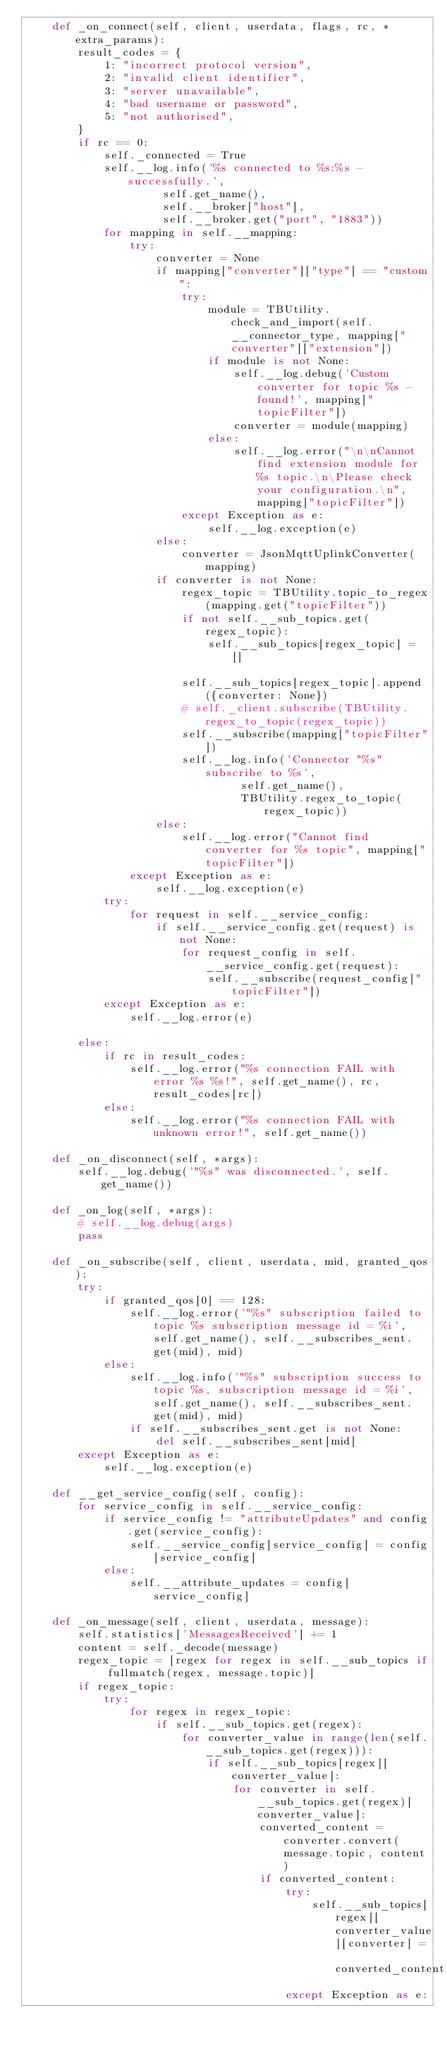Convert code to text. <code><loc_0><loc_0><loc_500><loc_500><_Python_>    def _on_connect(self, client, userdata, flags, rc, *extra_params):
        result_codes = {
            1: "incorrect protocol version",
            2: "invalid client identifier",
            3: "server unavailable",
            4: "bad username or password",
            5: "not authorised",
        }
        if rc == 0:
            self._connected = True
            self.__log.info('%s connected to %s:%s - successfully.',
                     self.get_name(),
                     self.__broker["host"],
                     self.__broker.get("port", "1883"))
            for mapping in self.__mapping:
                try:
                    converter = None
                    if mapping["converter"]["type"] == "custom":
                        try:
                            module = TBUtility.check_and_import(self.__connector_type, mapping["converter"]["extension"])
                            if module is not None:
                                self.__log.debug('Custom converter for topic %s - found!', mapping["topicFilter"])
                                converter = module(mapping)
                            else:
                                self.__log.error("\n\nCannot find extension module for %s topic.\n\Please check your configuration.\n", mapping["topicFilter"])
                        except Exception as e:
                            self.__log.exception(e)
                    else:
                        converter = JsonMqttUplinkConverter(mapping)
                    if converter is not None:
                        regex_topic = TBUtility.topic_to_regex(mapping.get("topicFilter"))
                        if not self.__sub_topics.get(regex_topic):
                            self.__sub_topics[regex_topic] = []

                        self.__sub_topics[regex_topic].append({converter: None})
                        # self._client.subscribe(TBUtility.regex_to_topic(regex_topic))
                        self.__subscribe(mapping["topicFilter"])
                        self.__log.info('Connector "%s" subscribe to %s',
                                 self.get_name(),
                                 TBUtility.regex_to_topic(regex_topic))
                    else:
                        self.__log.error("Cannot find converter for %s topic", mapping["topicFilter"])
                except Exception as e:
                    self.__log.exception(e)
            try:
                for request in self.__service_config:
                    if self.__service_config.get(request) is not None:
                        for request_config in self.__service_config.get(request):
                            self.__subscribe(request_config["topicFilter"])
            except Exception as e:
                self.__log.error(e)

        else:
            if rc in result_codes:
                self.__log.error("%s connection FAIL with error %s %s!", self.get_name(), rc, result_codes[rc])
            else:
                self.__log.error("%s connection FAIL with unknown error!", self.get_name())

    def _on_disconnect(self, *args):
        self.__log.debug('"%s" was disconnected.', self.get_name())

    def _on_log(self, *args):
        # self.__log.debug(args)
        pass

    def _on_subscribe(self, client, userdata, mid, granted_qos):
        try:
            if granted_qos[0] == 128:
                self.__log.error('"%s" subscription failed to topic %s subscription message id = %i', self.get_name(), self.__subscribes_sent.get(mid), mid)
            else:
                self.__log.info('"%s" subscription success to topic %s, subscription message id = %i', self.get_name(), self.__subscribes_sent.get(mid), mid)
                if self.__subscribes_sent.get is not None:
                    del self.__subscribes_sent[mid]
        except Exception as e:
            self.__log.exception(e)

    def __get_service_config(self, config):
        for service_config in self.__service_config:
            if service_config != "attributeUpdates" and config.get(service_config):
                self.__service_config[service_config] = config[service_config]
            else:
                self.__attribute_updates = config[service_config]

    def _on_message(self, client, userdata, message):
        self.statistics['MessagesReceived'] += 1
        content = self._decode(message)
        regex_topic = [regex for regex in self.__sub_topics if fullmatch(regex, message.topic)]
        if regex_topic:
            try:
                for regex in regex_topic:
                    if self.__sub_topics.get(regex):
                        for converter_value in range(len(self.__sub_topics.get(regex))):
                            if self.__sub_topics[regex][converter_value]:
                                for converter in self.__sub_topics.get(regex)[converter_value]:
                                    converted_content = converter.convert(message.topic, content)
                                    if converted_content:
                                        try:
                                            self.__sub_topics[regex][converter_value][converter] = converted_content
                                        except Exception as e:</code> 